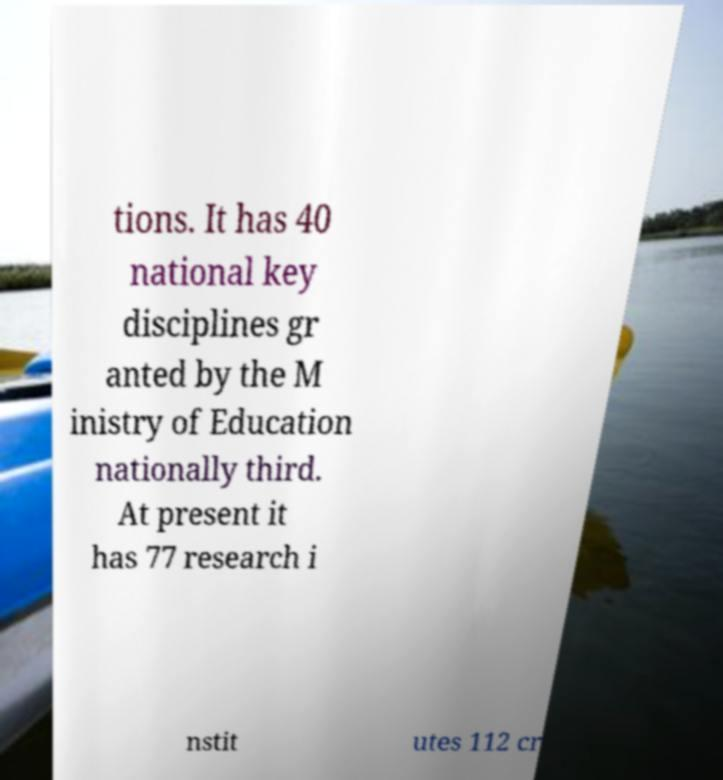I need the written content from this picture converted into text. Can you do that? tions. It has 40 national key disciplines gr anted by the M inistry of Education nationally third. At present it has 77 research i nstit utes 112 cr 